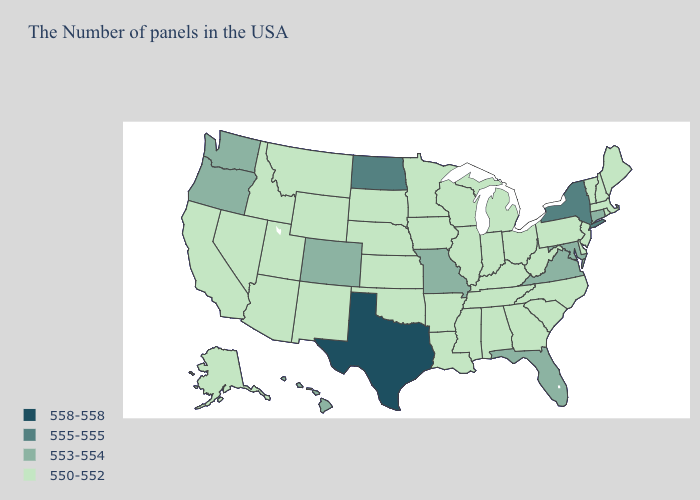Which states have the lowest value in the West?
Keep it brief. Wyoming, New Mexico, Utah, Montana, Arizona, Idaho, Nevada, California, Alaska. Does Alabama have the lowest value in the South?
Give a very brief answer. Yes. Does the first symbol in the legend represent the smallest category?
Concise answer only. No. Which states hav the highest value in the West?
Keep it brief. Colorado, Washington, Oregon, Hawaii. Name the states that have a value in the range 558-558?
Be succinct. Texas. What is the value of Louisiana?
Quick response, please. 550-552. Does Missouri have the lowest value in the MidWest?
Concise answer only. No. What is the highest value in the USA?
Concise answer only. 558-558. Name the states that have a value in the range 550-552?
Answer briefly. Maine, Massachusetts, Rhode Island, New Hampshire, Vermont, New Jersey, Delaware, Pennsylvania, North Carolina, South Carolina, West Virginia, Ohio, Georgia, Michigan, Kentucky, Indiana, Alabama, Tennessee, Wisconsin, Illinois, Mississippi, Louisiana, Arkansas, Minnesota, Iowa, Kansas, Nebraska, Oklahoma, South Dakota, Wyoming, New Mexico, Utah, Montana, Arizona, Idaho, Nevada, California, Alaska. Which states have the highest value in the USA?
Be succinct. Texas. Among the states that border Connecticut , which have the highest value?
Be succinct. New York. How many symbols are there in the legend?
Concise answer only. 4. Name the states that have a value in the range 553-554?
Answer briefly. Connecticut, Maryland, Virginia, Florida, Missouri, Colorado, Washington, Oregon, Hawaii. What is the highest value in the Northeast ?
Keep it brief. 555-555. 